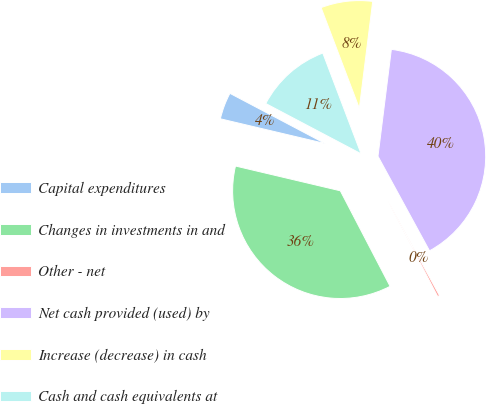Convert chart to OTSL. <chart><loc_0><loc_0><loc_500><loc_500><pie_chart><fcel>Capital expenditures<fcel>Changes in investments in and<fcel>Other - net<fcel>Net cash provided (used) by<fcel>Increase (decrease) in cash<fcel>Cash and cash equivalents at<nl><fcel>4.03%<fcel>36.34%<fcel>0.3%<fcel>40.08%<fcel>7.76%<fcel>11.5%<nl></chart> 